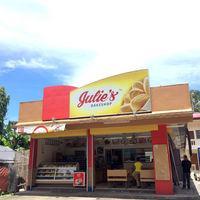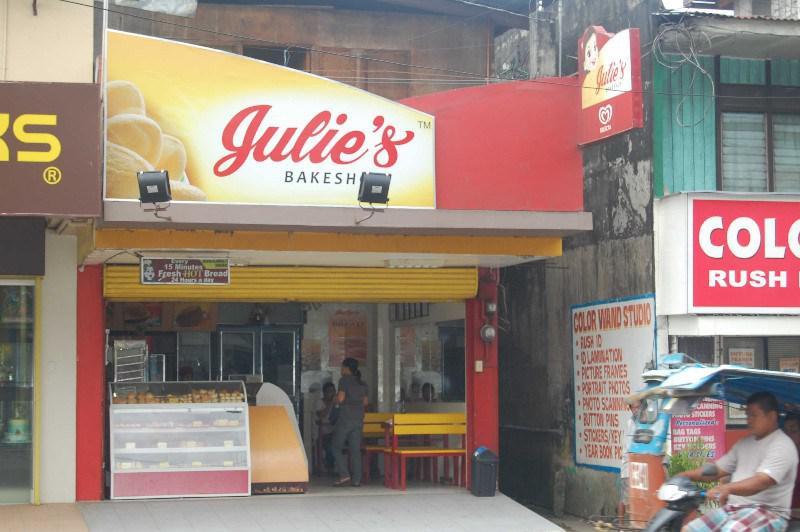The first image is the image on the left, the second image is the image on the right. Assess this claim about the two images: "These stores feature different names in each image of the set.". Correct or not? Answer yes or no. No. 